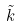Convert formula to latex. <formula><loc_0><loc_0><loc_500><loc_500>\tilde { k }</formula> 